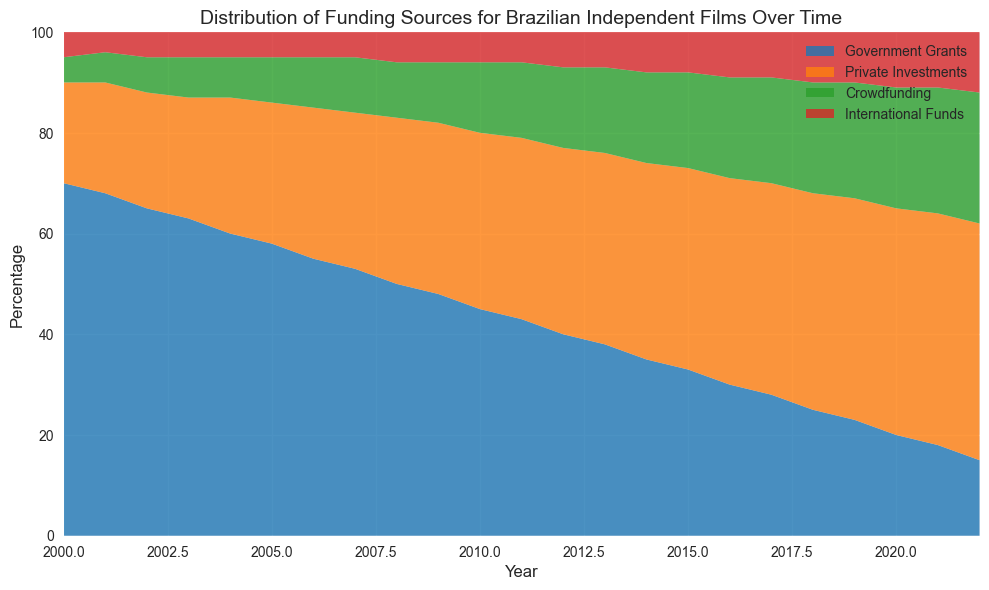What is the general trend in the percentage of Government Grants from 2000 to 2022? The curve representing Government Grants consistently declines over the years from 70% in 2000 to 15% in 2022.
Answer: Consistently declining Which funding source has the highest percentage in 2022? In 2022, among the colors showing different funding sources, Private Investments (shown in a distinct color like orange or similar) has the highest visible area, indicating the highest percentage.
Answer: Private Investments Compare the percentage of Crowdfunding and International Funds in 2010. Which one is higher? In 2010, Crowdfunding (represented in a particular color like green) has a visibly larger area compared to International Funds (represented in another color like red). Hence, Crowdfunding has a higher percentage in 2010.
Answer: Crowdfunding In which year does Private Investments surpass Government Grants in funding? Observing the points where the curves for Private Investments and Government Grants intersect, it is clear that in 2010, the curve for Private Investments goes above the Government Grants curve.
Answer: 2010 What is the difference in the percentage of Private Investments between 2000 and 2022? To find this difference, subtract the percentage of Private Investments in 2000 (20%) from the percentage in 2022 (47%). This results in 47% - 20% = 27%.
Answer: 27% Which year has the highest combined percentage of Crowdfunding and International Funds? To identify this, look for the peak area representing Crowdfunding and International Funds combined. It seems to occur in 2022 with Crowdfunding and International Funds summing up to 26% + 12% = 38%.
Answer: 2022 Calculate the average percentage of Government Grants from 2000 to 2005. Add the percentages of Government Grants from 2000 to 2005 and divide by 6: (70 + 68 + 65 + 63 + 60 + 58) / 6 = 384 / 6 = 64%.
Answer: 64% Compare the contribution of Private Investments in 2010 and 2015. By how much did it increase? The percentage of Private Investments in 2010 is 35%, and in 2015 it is 40%. The increase is 40% - 35% = 5%.
Answer: 5% How does the percentage of Government Grants in 2020 compare to its percentage in 2000? In 2000, Government Grants are at 70%, and in 2020, they are at 20%. Comparing the two shows a significant decrease by 70% - 20% = 50%.
Answer: Decreased by 50% Determine the highest point of Crowdfunding over the years. The highest point of Crowdfunding occurs in 2022, reaching 26% as seen at the top area within its color segment.
Answer: 26% 